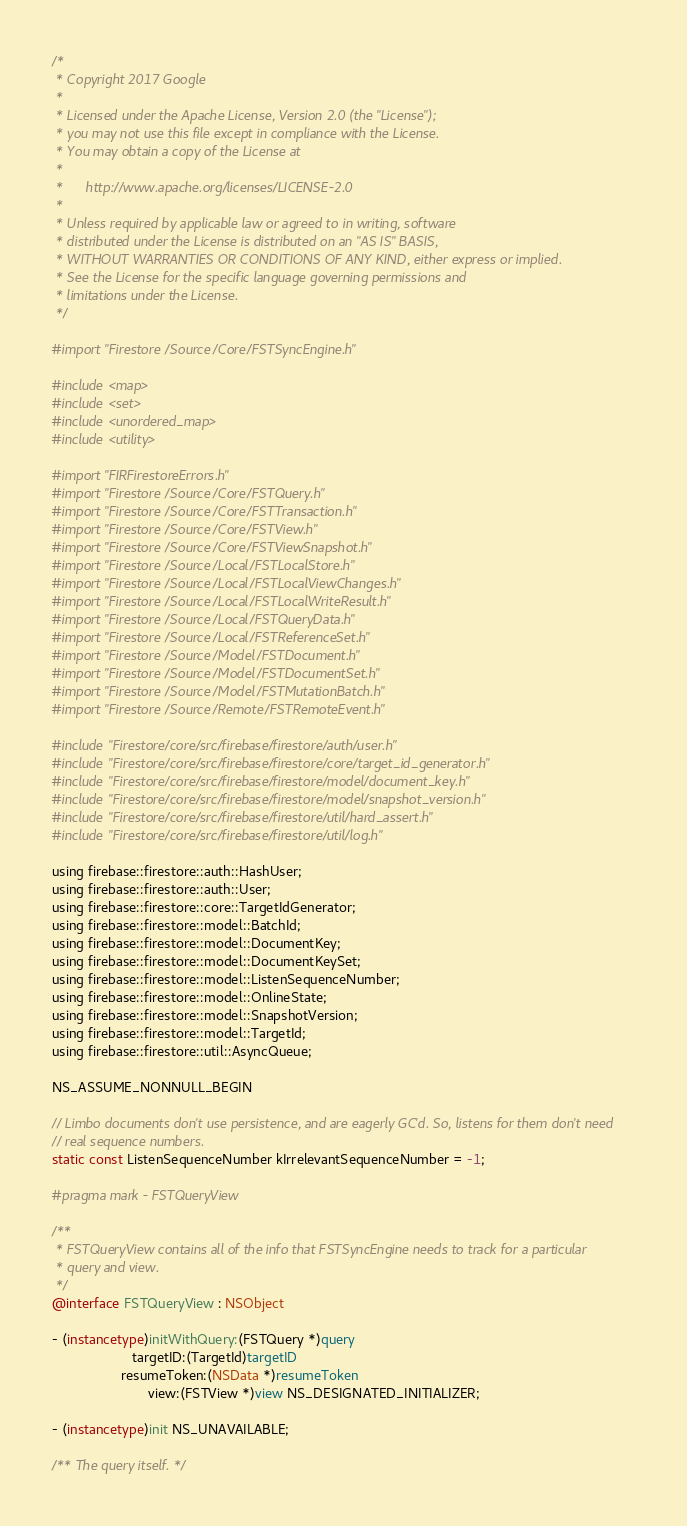<code> <loc_0><loc_0><loc_500><loc_500><_ObjectiveC_>/*
 * Copyright 2017 Google
 *
 * Licensed under the Apache License, Version 2.0 (the "License");
 * you may not use this file except in compliance with the License.
 * You may obtain a copy of the License at
 *
 *      http://www.apache.org/licenses/LICENSE-2.0
 *
 * Unless required by applicable law or agreed to in writing, software
 * distributed under the License is distributed on an "AS IS" BASIS,
 * WITHOUT WARRANTIES OR CONDITIONS OF ANY KIND, either express or implied.
 * See the License for the specific language governing permissions and
 * limitations under the License.
 */

#import "Firestore/Source/Core/FSTSyncEngine.h"

#include <map>
#include <set>
#include <unordered_map>
#include <utility>

#import "FIRFirestoreErrors.h"
#import "Firestore/Source/Core/FSTQuery.h"
#import "Firestore/Source/Core/FSTTransaction.h"
#import "Firestore/Source/Core/FSTView.h"
#import "Firestore/Source/Core/FSTViewSnapshot.h"
#import "Firestore/Source/Local/FSTLocalStore.h"
#import "Firestore/Source/Local/FSTLocalViewChanges.h"
#import "Firestore/Source/Local/FSTLocalWriteResult.h"
#import "Firestore/Source/Local/FSTQueryData.h"
#import "Firestore/Source/Local/FSTReferenceSet.h"
#import "Firestore/Source/Model/FSTDocument.h"
#import "Firestore/Source/Model/FSTDocumentSet.h"
#import "Firestore/Source/Model/FSTMutationBatch.h"
#import "Firestore/Source/Remote/FSTRemoteEvent.h"

#include "Firestore/core/src/firebase/firestore/auth/user.h"
#include "Firestore/core/src/firebase/firestore/core/target_id_generator.h"
#include "Firestore/core/src/firebase/firestore/model/document_key.h"
#include "Firestore/core/src/firebase/firestore/model/snapshot_version.h"
#include "Firestore/core/src/firebase/firestore/util/hard_assert.h"
#include "Firestore/core/src/firebase/firestore/util/log.h"

using firebase::firestore::auth::HashUser;
using firebase::firestore::auth::User;
using firebase::firestore::core::TargetIdGenerator;
using firebase::firestore::model::BatchId;
using firebase::firestore::model::DocumentKey;
using firebase::firestore::model::DocumentKeySet;
using firebase::firestore::model::ListenSequenceNumber;
using firebase::firestore::model::OnlineState;
using firebase::firestore::model::SnapshotVersion;
using firebase::firestore::model::TargetId;
using firebase::firestore::util::AsyncQueue;

NS_ASSUME_NONNULL_BEGIN

// Limbo documents don't use persistence, and are eagerly GC'd. So, listens for them don't need
// real sequence numbers.
static const ListenSequenceNumber kIrrelevantSequenceNumber = -1;

#pragma mark - FSTQueryView

/**
 * FSTQueryView contains all of the info that FSTSyncEngine needs to track for a particular
 * query and view.
 */
@interface FSTQueryView : NSObject

- (instancetype)initWithQuery:(FSTQuery *)query
                     targetID:(TargetId)targetID
                  resumeToken:(NSData *)resumeToken
                         view:(FSTView *)view NS_DESIGNATED_INITIALIZER;

- (instancetype)init NS_UNAVAILABLE;

/** The query itself. */</code> 